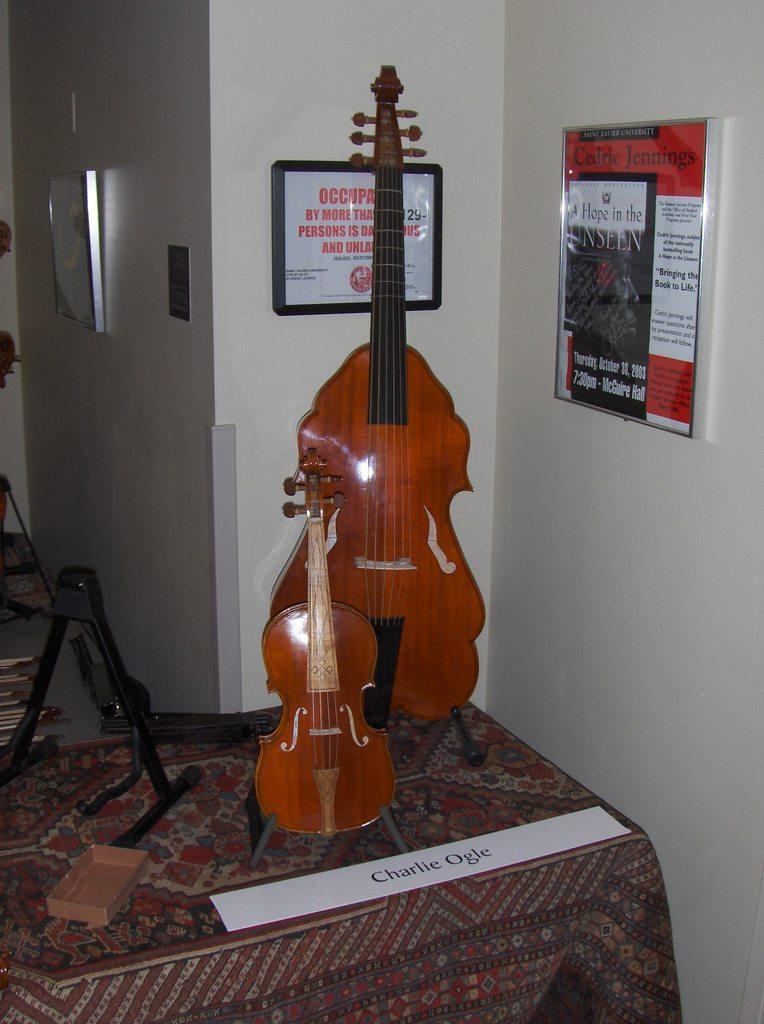Please provide a concise description of this image. In this image I can see a musical instrument on the table. At the back side the frame is attached to the wall. 